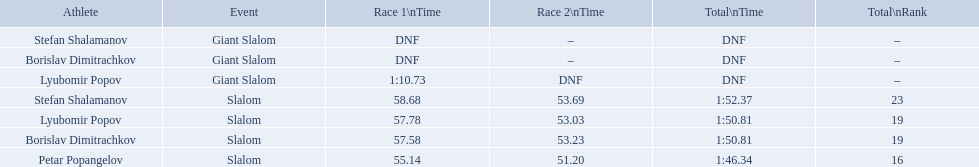Among the athletes, who had a race time of more than 1:00? Lyubomir Popov. 